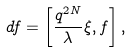Convert formula to latex. <formula><loc_0><loc_0><loc_500><loc_500>d f = \left [ \frac { q ^ { 2 N } } { \lambda } \xi , f \right ] ,</formula> 